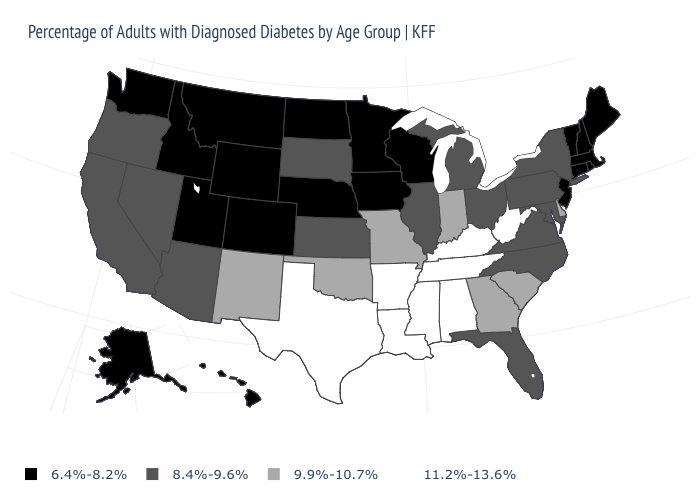Name the states that have a value in the range 8.4%-9.6%?
Write a very short answer. Arizona, California, Florida, Illinois, Kansas, Maryland, Michigan, Nevada, New York, North Carolina, Ohio, Oregon, Pennsylvania, South Dakota, Virginia. What is the value of South Carolina?
Be succinct. 9.9%-10.7%. Which states hav the highest value in the MidWest?
Answer briefly. Indiana, Missouri. Does Missouri have the same value as Indiana?
Give a very brief answer. Yes. Which states have the lowest value in the USA?
Keep it brief. Alaska, Colorado, Connecticut, Hawaii, Idaho, Iowa, Maine, Massachusetts, Minnesota, Montana, Nebraska, New Hampshire, New Jersey, North Dakota, Rhode Island, Utah, Vermont, Washington, Wisconsin, Wyoming. Does Delaware have the highest value in the South?
Write a very short answer. No. Among the states that border Nebraska , does Wyoming have the lowest value?
Give a very brief answer. Yes. Name the states that have a value in the range 11.2%-13.6%?
Give a very brief answer. Alabama, Arkansas, Kentucky, Louisiana, Mississippi, Tennessee, Texas, West Virginia. What is the value of Maine?
Answer briefly. 6.4%-8.2%. What is the highest value in states that border Connecticut?
Be succinct. 8.4%-9.6%. Which states hav the highest value in the MidWest?
Short answer required. Indiana, Missouri. Does the map have missing data?
Be succinct. No. What is the value of California?
Write a very short answer. 8.4%-9.6%. Which states have the lowest value in the USA?
Be succinct. Alaska, Colorado, Connecticut, Hawaii, Idaho, Iowa, Maine, Massachusetts, Minnesota, Montana, Nebraska, New Hampshire, New Jersey, North Dakota, Rhode Island, Utah, Vermont, Washington, Wisconsin, Wyoming. What is the value of Utah?
Answer briefly. 6.4%-8.2%. 